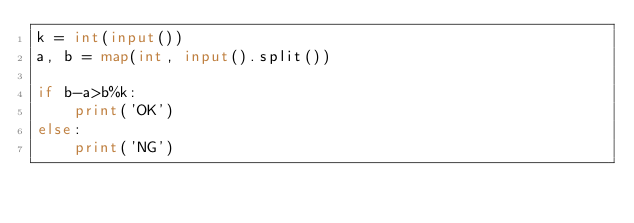<code> <loc_0><loc_0><loc_500><loc_500><_Python_>k = int(input())
a, b = map(int, input().split())

if b-a>b%k:
    print('OK')
else:
    print('NG')</code> 